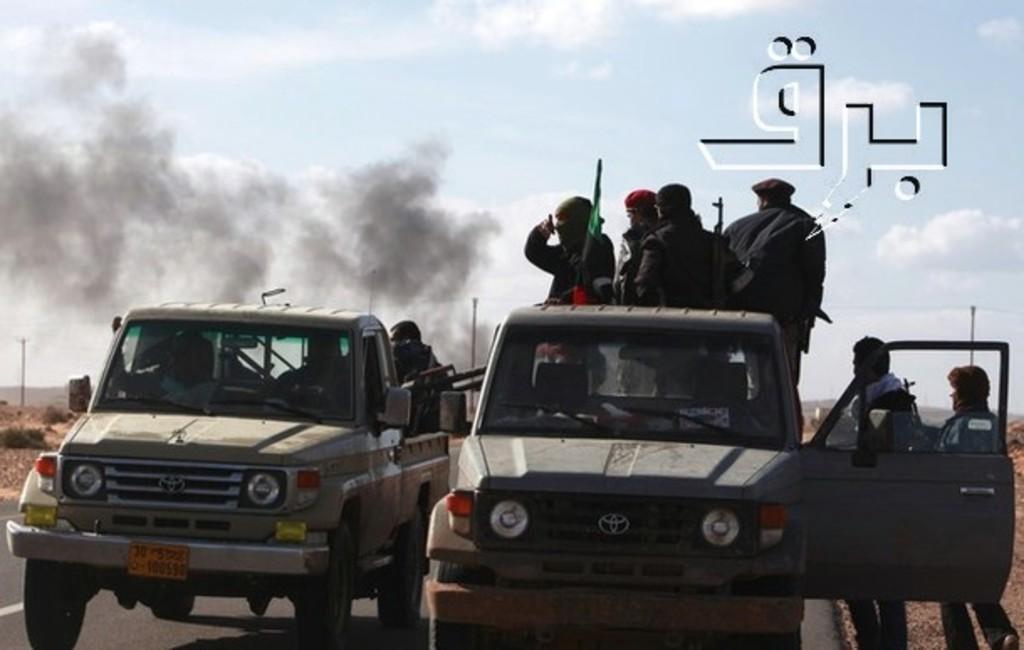How would you summarize this image in a sentence or two? This picture is of outside. On the right there are two persons standing behind the front door of a Car. In the center we can see there are two cars in which there are group of persons. In the background we can see the sky, clouds, smoke, pole, ground and on the right there is a watermark on the image. 